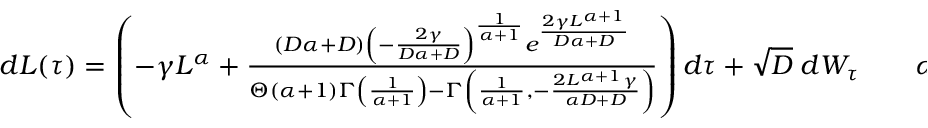Convert formula to latex. <formula><loc_0><loc_0><loc_500><loc_500>\begin{array} { r } { d L ( \tau ) = \left ( - \gamma L ^ { \alpha } + \frac { ( D \alpha + D ) \left ( - \frac { 2 \gamma } { D \alpha + D } \right ) ^ { \frac { 1 } { \alpha + 1 } } e ^ { \frac { 2 \gamma L ^ { \alpha + 1 } } { D \alpha + D } } } { \Theta ( \alpha + 1 ) \Gamma \left ( \frac { 1 } { \alpha + 1 } \right ) - \Gamma \left ( \frac { 1 } { \alpha + 1 } , - \frac { 2 L ^ { \alpha + 1 } \gamma } { \alpha D + D } \right ) } \right ) d \tau + \sqrt { D } \, d W _ { \tau } \quad \alpha \neq - 1 \ , } \end{array}</formula> 